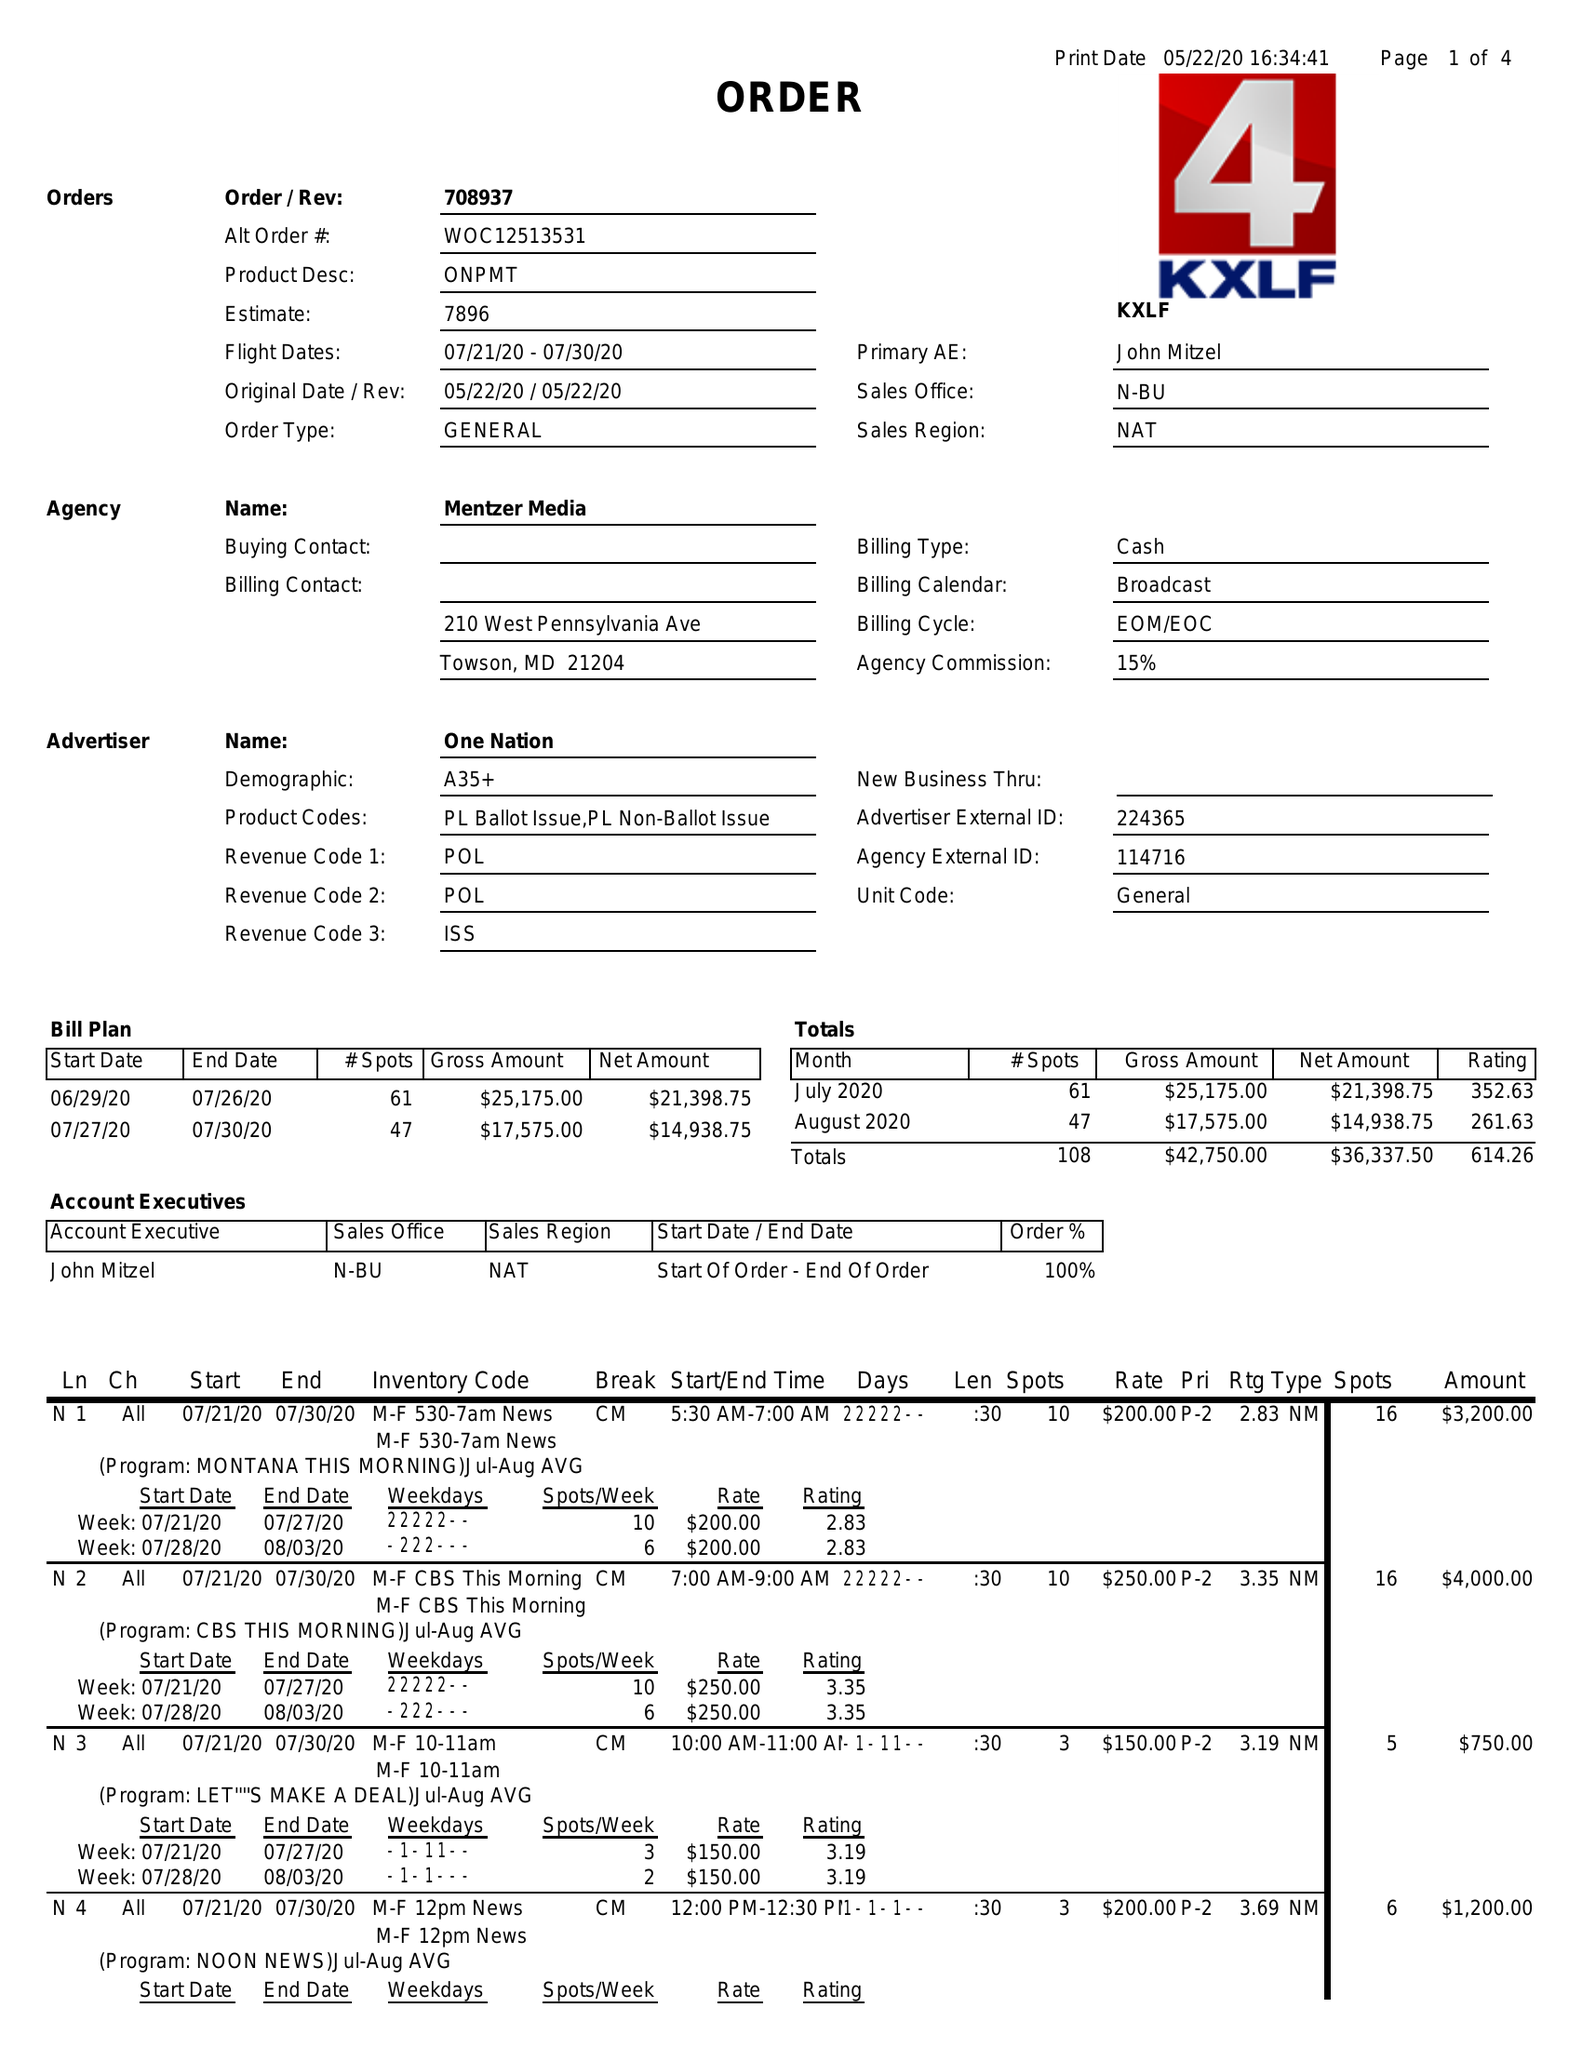What is the value for the flight_to?
Answer the question using a single word or phrase. 07/30/20 